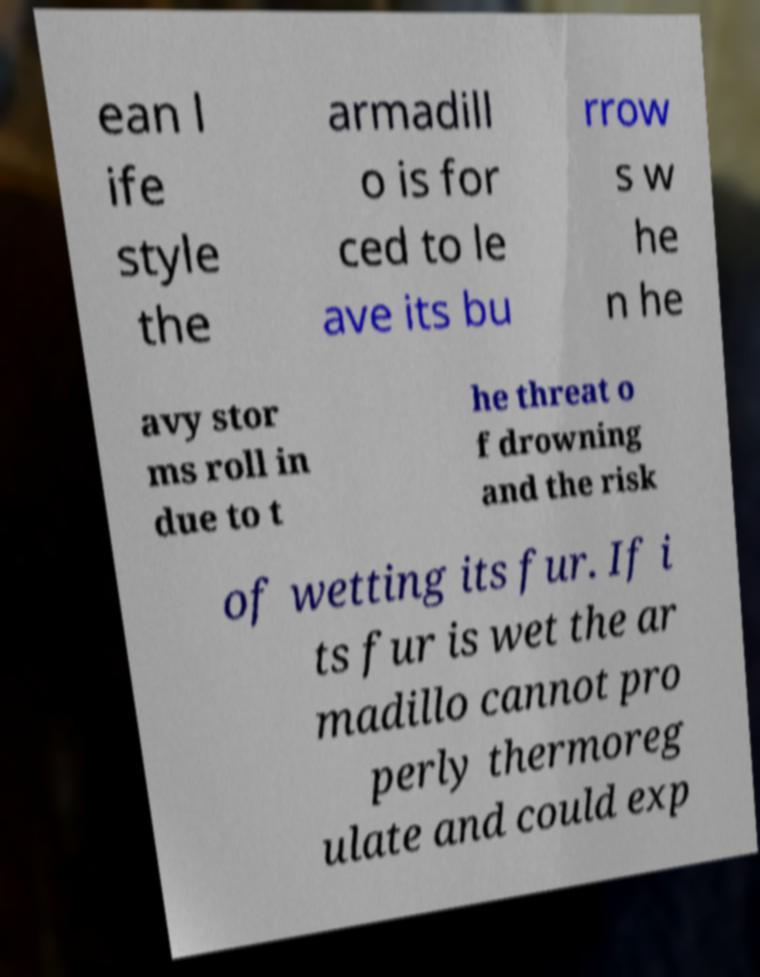There's text embedded in this image that I need extracted. Can you transcribe it verbatim? ean l ife style the armadill o is for ced to le ave its bu rrow s w he n he avy stor ms roll in due to t he threat o f drowning and the risk of wetting its fur. If i ts fur is wet the ar madillo cannot pro perly thermoreg ulate and could exp 